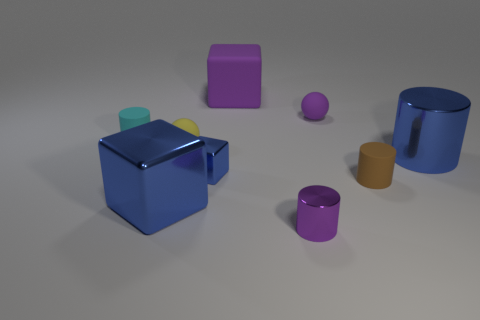Subtract all blue cubes. How many cubes are left? 1 Subtract all brown spheres. How many brown blocks are left? 0 Subtract all yellow spheres. How many spheres are left? 1 Subtract all cubes. How many objects are left? 6 Subtract all blue cubes. Subtract all brown cylinders. How many cubes are left? 1 Subtract all large rubber blocks. Subtract all big cylinders. How many objects are left? 7 Add 4 tiny blue objects. How many tiny blue objects are left? 5 Add 4 brown cylinders. How many brown cylinders exist? 5 Subtract 0 brown cubes. How many objects are left? 9 Subtract 1 spheres. How many spheres are left? 1 